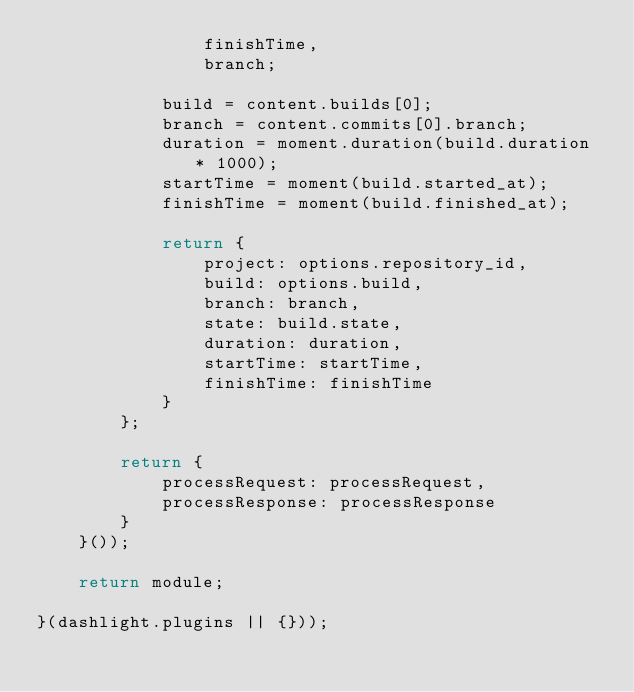<code> <loc_0><loc_0><loc_500><loc_500><_JavaScript_>                finishTime,
                branch;

            build = content.builds[0];
            branch = content.commits[0].branch;
            duration = moment.duration(build.duration * 1000);
            startTime = moment(build.started_at);
            finishTime = moment(build.finished_at);

            return {
                project: options.repository_id,
                build: options.build,
                branch: branch,
                state: build.state,
                duration: duration,
                startTime: startTime,
                finishTime: finishTime
            }
        };

        return {
            processRequest: processRequest,
            processResponse: processResponse
        }
    }());

    return module;

}(dashlight.plugins || {}));
</code> 